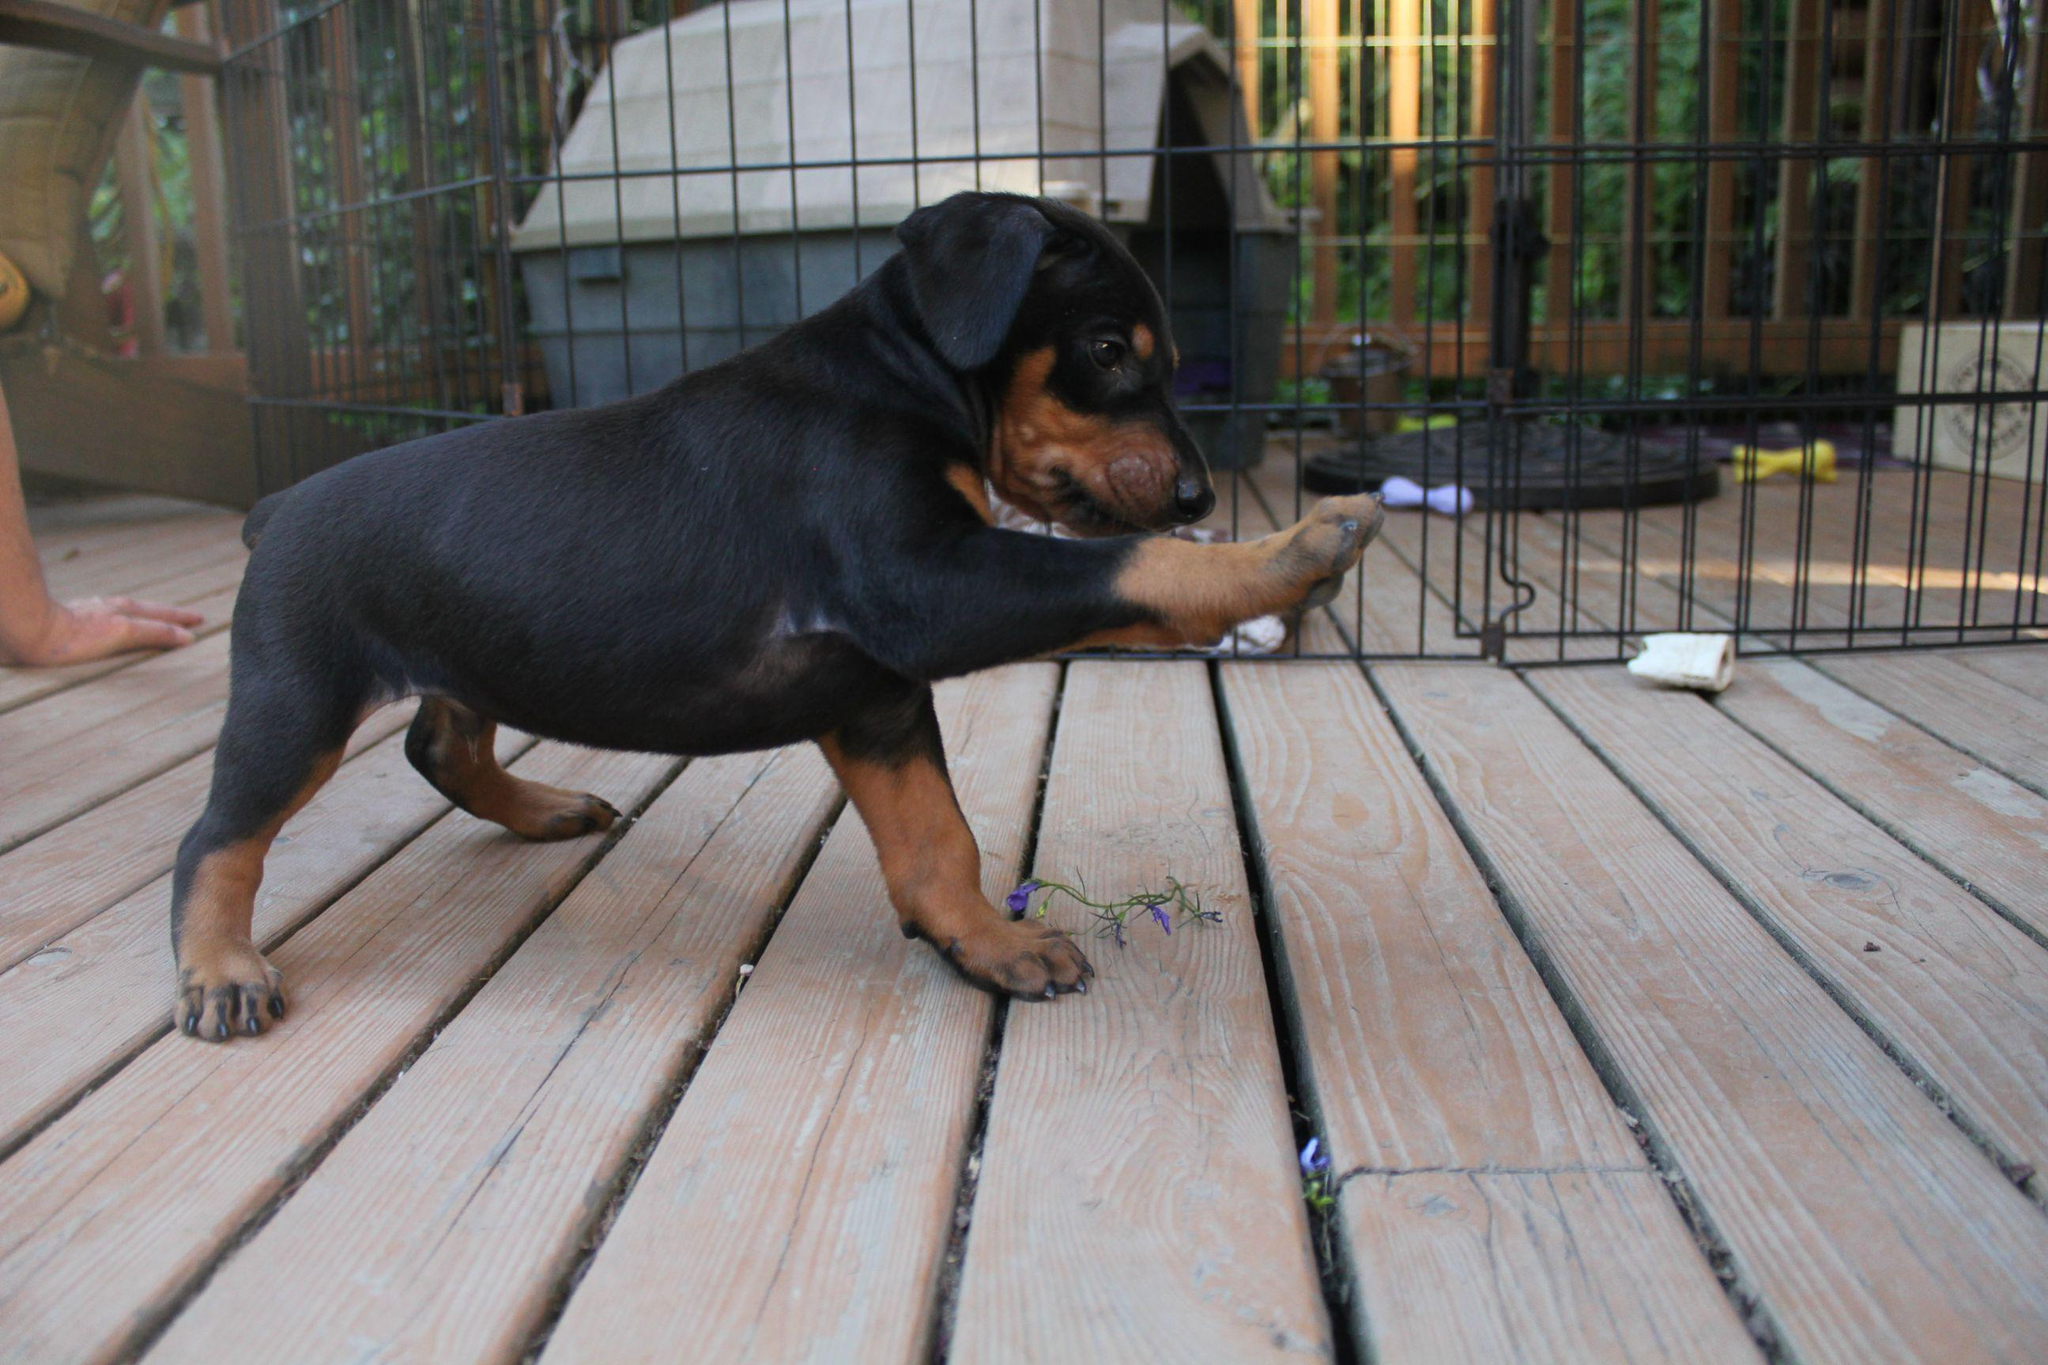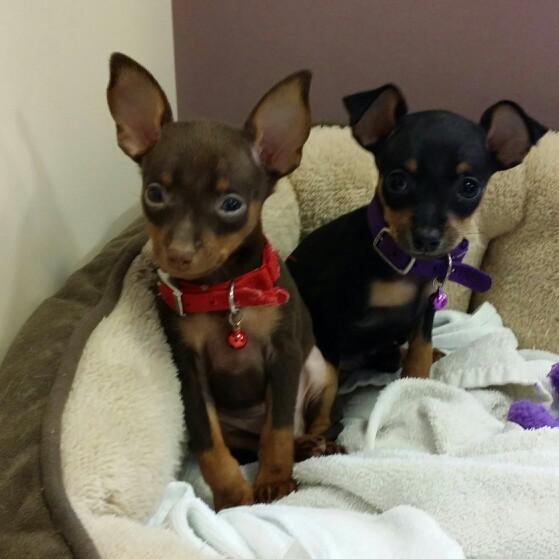The first image is the image on the left, the second image is the image on the right. Examine the images to the left and right. Is the description "At least one of the dogs is standing on all fours." accurate? Answer yes or no. Yes. The first image is the image on the left, the second image is the image on the right. Evaluate the accuracy of this statement regarding the images: "The right image features at least two puppies sitting upright with faces forward on a plush white blanket.". Is it true? Answer yes or no. Yes. 